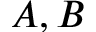Convert formula to latex. <formula><loc_0><loc_0><loc_500><loc_500>A , B</formula> 